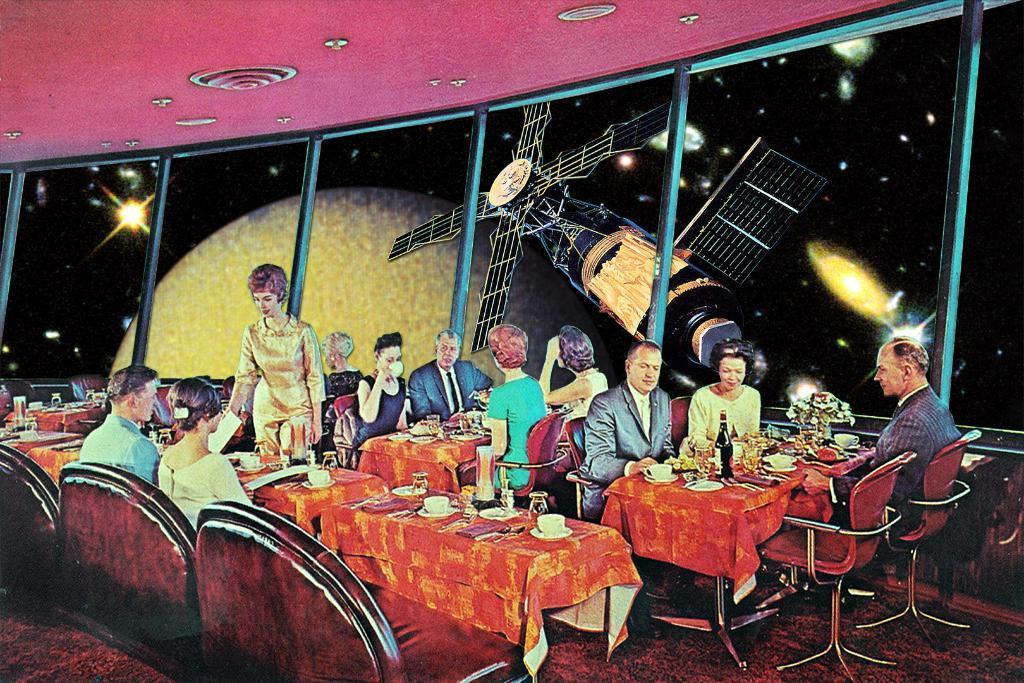In one or two sentences, can you explain what this image depicts? This is a painting of an image. In the image there are few people sitting on the chairs and in front of them there are table. On the tables there are cups, bottles, plates and some other things. There is a lady standing in the image. In the background there are glass walls. Behind them there are satellite, stars, moon and planets. 